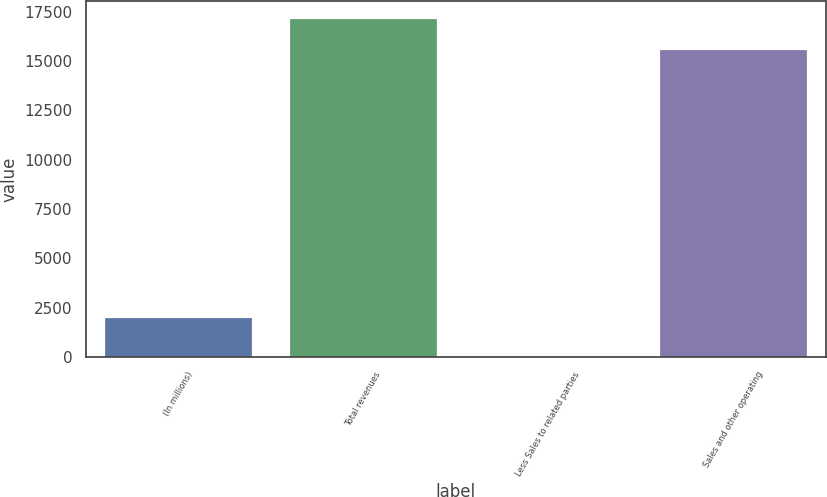Convert chart to OTSL. <chart><loc_0><loc_0><loc_500><loc_500><bar_chart><fcel>(In millions)<fcel>Total revenues<fcel>Less Sales to related parties<fcel>Sales and other operating<nl><fcel>2012<fcel>17193<fcel>58<fcel>15630<nl></chart> 